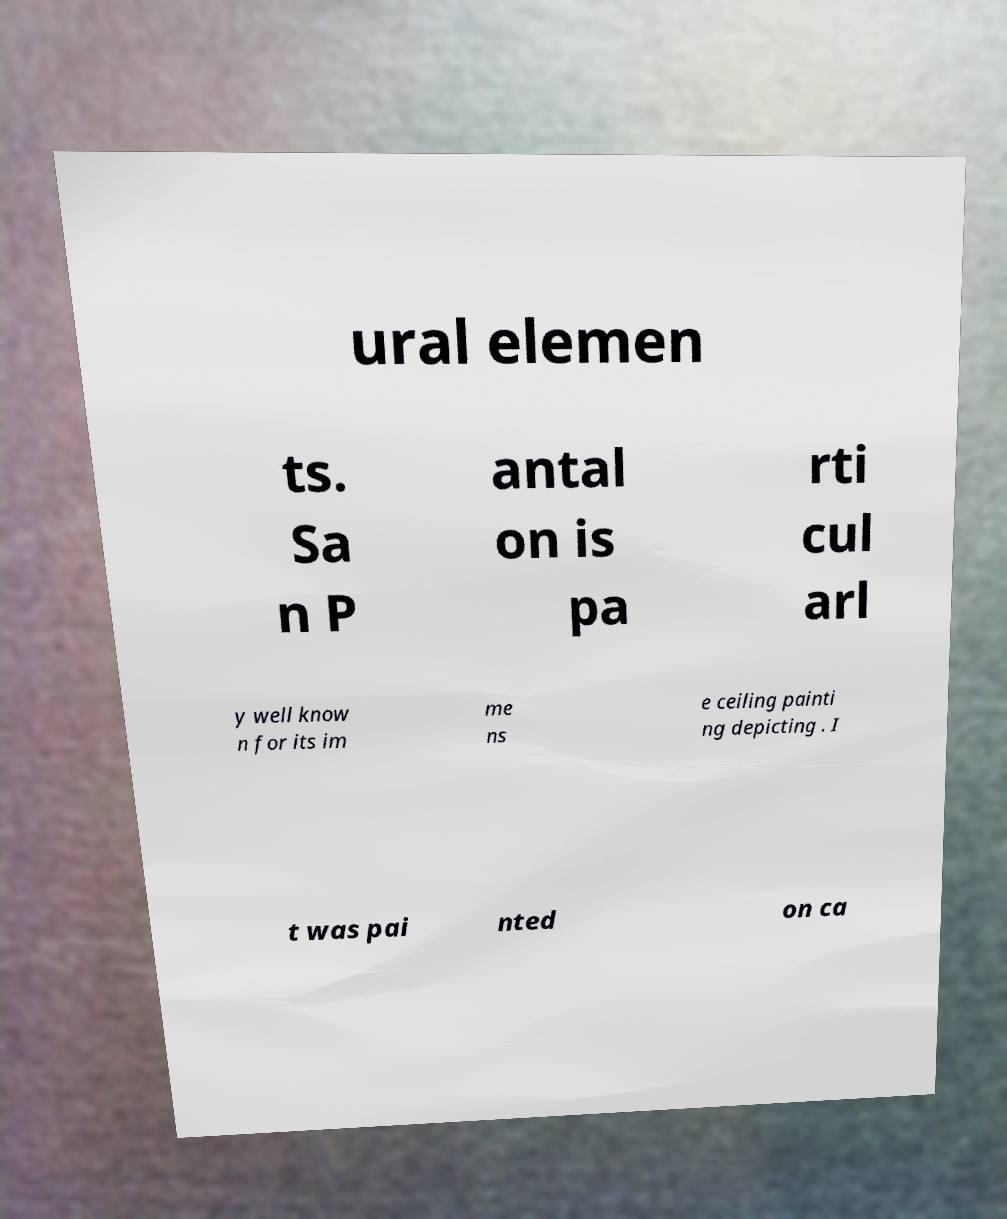There's text embedded in this image that I need extracted. Can you transcribe it verbatim? ural elemen ts. Sa n P antal on is pa rti cul arl y well know n for its im me ns e ceiling painti ng depicting . I t was pai nted on ca 